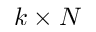<formula> <loc_0><loc_0><loc_500><loc_500>k \times N</formula> 